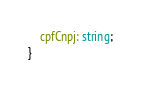Convert code to text. <code><loc_0><loc_0><loc_500><loc_500><_TypeScript_>    cpfCnpj: string;
}</code> 